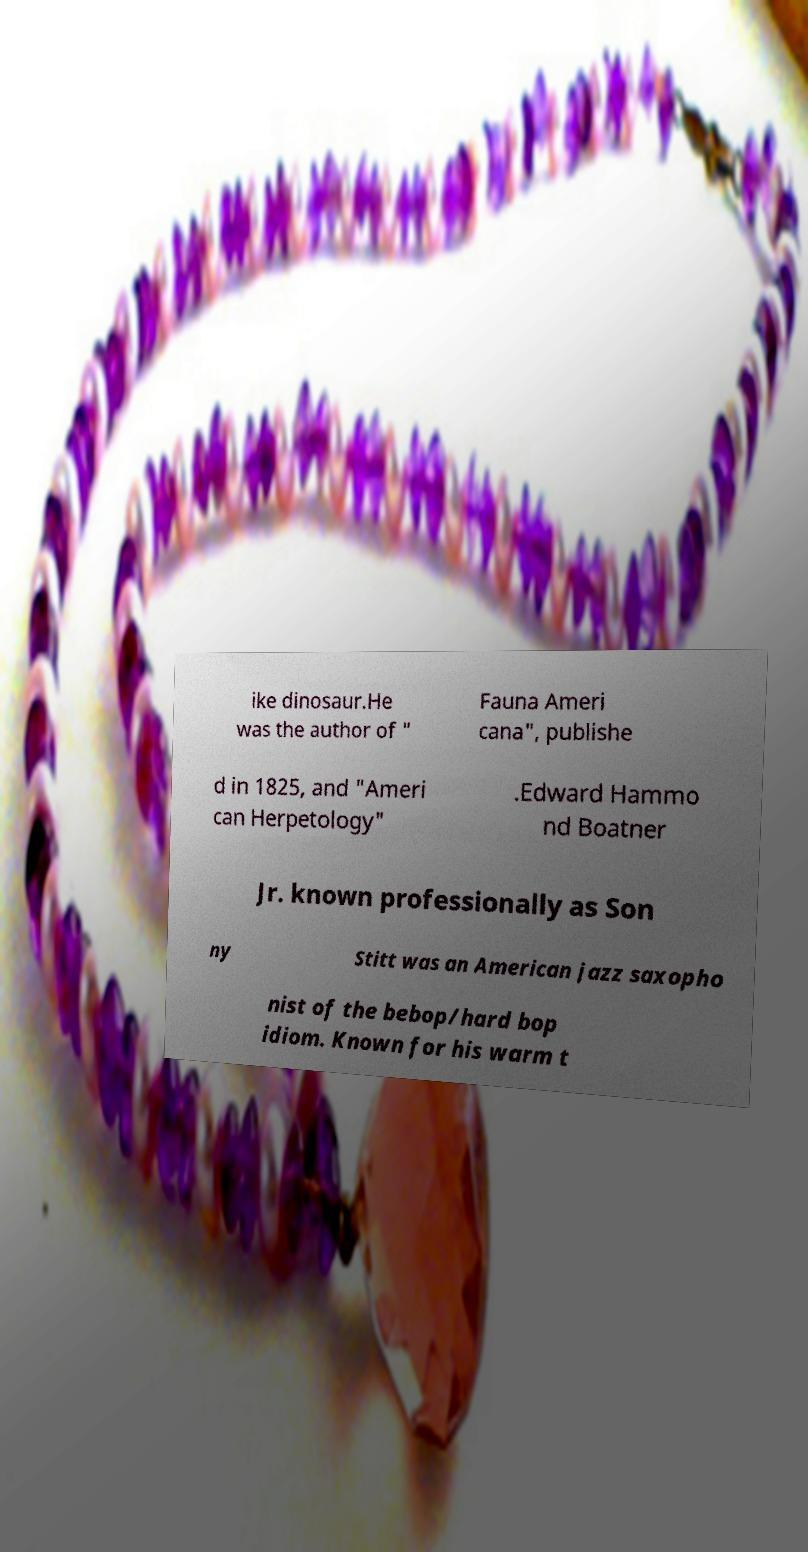Please read and relay the text visible in this image. What does it say? ike dinosaur.He was the author of " Fauna Ameri cana", publishe d in 1825, and "Ameri can Herpetology" .Edward Hammo nd Boatner Jr. known professionally as Son ny Stitt was an American jazz saxopho nist of the bebop/hard bop idiom. Known for his warm t 